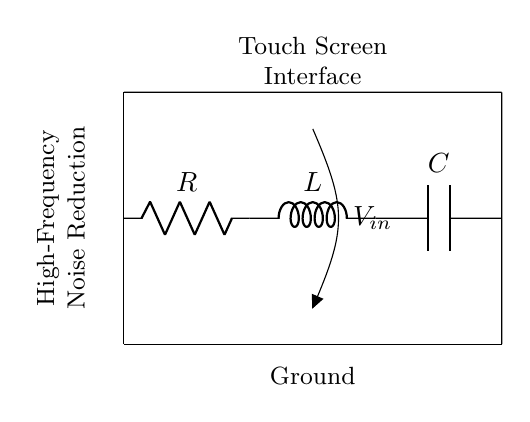What is the component connected to the left of the inductor? The component to the left of the inductor is a resistor, which is indicated by the symbol R in the diagram.
Answer: Resistor What is the function of this circuit? The circuit is designed for high-frequency noise reduction in touch screen interfaces, as indicated by the accompanying text.
Answer: Noise reduction What type of circuit configuration is shown? The circuit presents a parallel configuration since the components R, L, and C are connected in parallel between two nodes.
Answer: Parallel What is the voltage notation used in the circuit? The voltage notation used in the circuit is v^>, indicating the input voltage is applied across the parallel elements.
Answer: Vin Which component opposes high-frequency signals? The inductor L opposes high-frequency signals in this circuit due to its behavior in response to changing currents.
Answer: Inductor How does the capacitor behave at high frequencies? The capacitor C shunts high-frequency noise to ground, effectively allowing it to bypass the load and reduce interference.
Answer: Shunts noise What would happen if the resistor value is increased? Increasing the resistor value would decrease current flow through the circuit, which might lead to less effective noise reduction due to altered damping.
Answer: Decreased current flow 